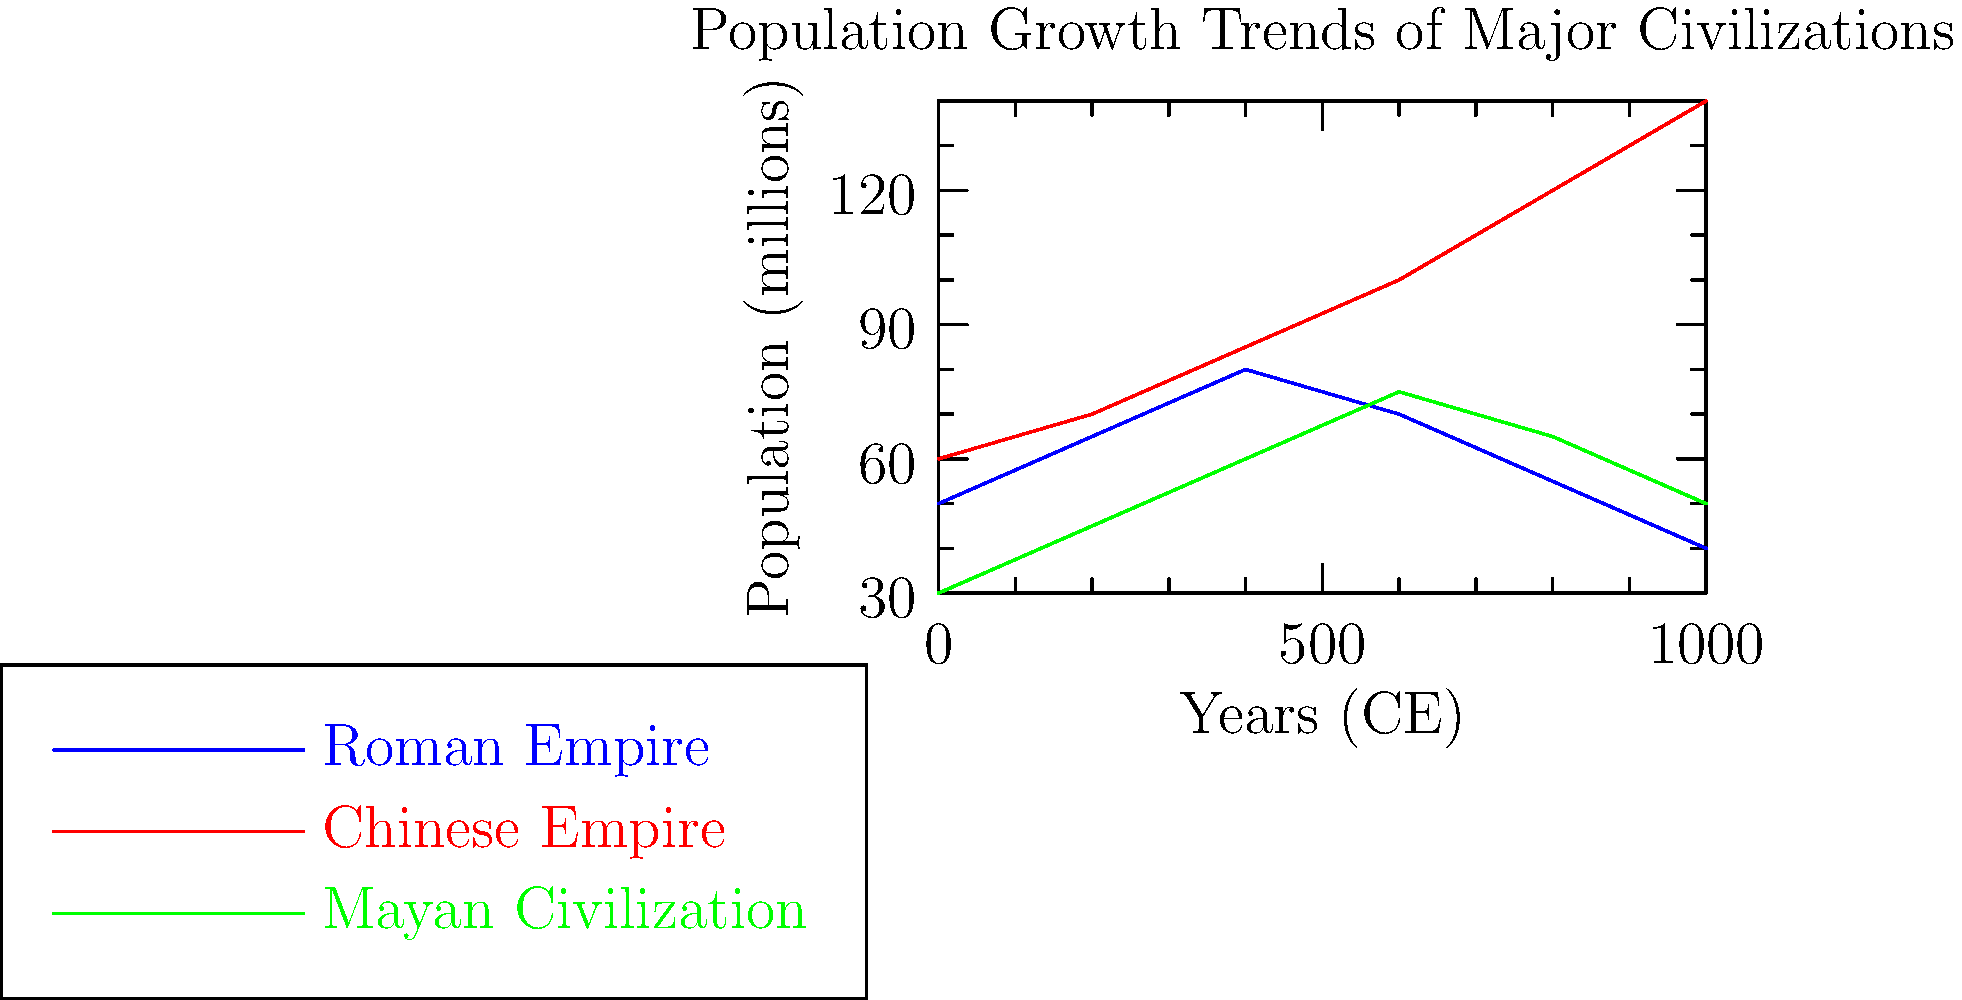Based on the line graph comparing population growth trends of major civilizations, which empire demonstrated the most consistent and substantial growth over the entire period shown? Explain the factors that might have contributed to this trend and how it contrasts with the other civilizations depicted. To answer this question, we need to analyze the growth patterns of each civilization:

1. Roman Empire (blue line):
   - Started around 50 million in 0 CE
   - Grew until about 400 CE, reaching approximately 80 million
   - Declined steadily after 400 CE, ending at about 40 million in 1000 CE

2. Chinese Empire (red line):
   - Started around 60 million in 0 CE
   - Showed consistent growth throughout the entire period
   - Ended at approximately 140 million in 1000 CE

3. Mayan Civilization (green line):
   - Started around 30 million in 0 CE
   - Grew until about 600 CE, reaching approximately 75 million
   - Declined after 600 CE, ending at about 50 million in 1000 CE

The Chinese Empire demonstrates the most consistent and substantial growth over the entire period. Factors contributing to this trend might include:

1. Stable political systems and dynastic cycles
2. Advanced agricultural techniques and land management
3. Technological innovations
4. Effective bureaucratic administration
5. Relative isolation from external invasions compared to other civilizations

In contrast, the Roman Empire showed growth followed by decline, possibly due to:
- Internal political instability
- Economic challenges
- External invasions and pressures

The Mayan Civilization exhibited growth followed by a less severe decline, which might be attributed to:
- Environmental factors (e.g., drought)
- Social and political upheaval
- Resource depletion

The Chinese Empire's consistent growth sets it apart from the other two civilizations, which experienced periods of decline after initial growth.
Answer: The Chinese Empire, due to stable political systems, advanced agriculture, technological innovations, and effective administration. 